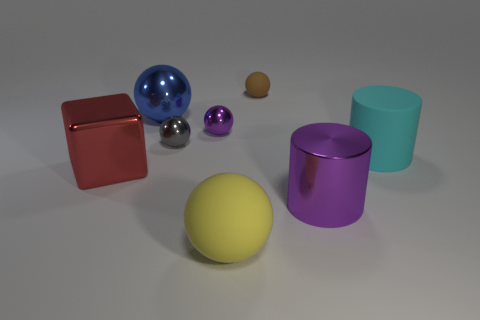Subtract all gray balls. How many balls are left? 4 Subtract all yellow rubber spheres. How many spheres are left? 4 Subtract all red spheres. Subtract all cyan cylinders. How many spheres are left? 5 Add 1 large yellow cylinders. How many objects exist? 9 Subtract all blocks. How many objects are left? 7 Subtract all red objects. Subtract all purple things. How many objects are left? 5 Add 3 large purple objects. How many large purple objects are left? 4 Add 7 small green blocks. How many small green blocks exist? 7 Subtract 0 brown cylinders. How many objects are left? 8 